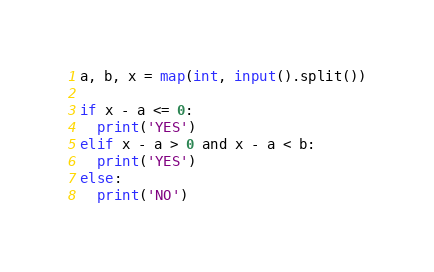Convert code to text. <code><loc_0><loc_0><loc_500><loc_500><_Python_>a, b, x = map(int, input().split())

if x - a <= 0:
  print('YES')
elif x - a > 0 and x - a < b:
  print('YES')  
else:
  print('NO')</code> 